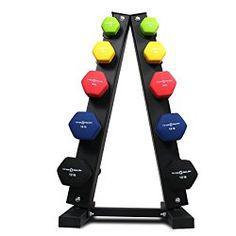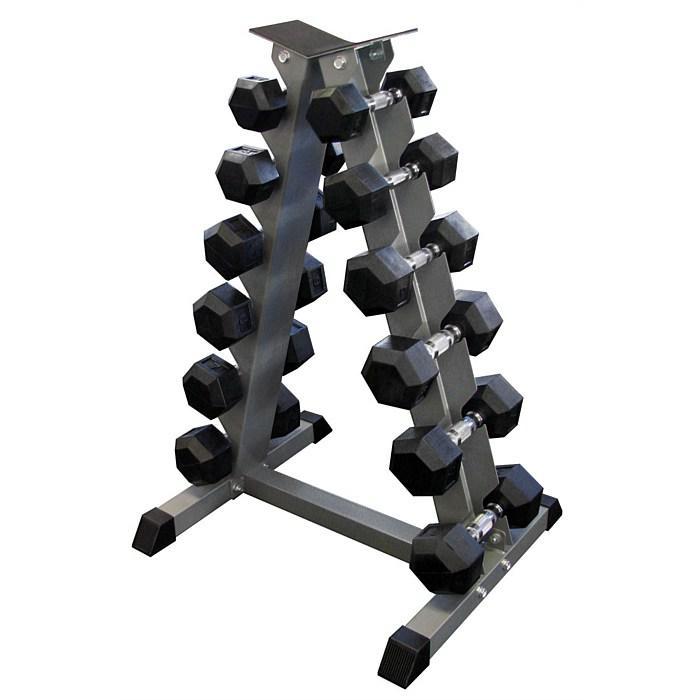The first image is the image on the left, the second image is the image on the right. Examine the images to the left and right. Is the description "Two metal racks for weights are trangular shaped, one of them black with various colored weights, the other gray with black weights." accurate? Answer yes or no. Yes. The first image is the image on the left, the second image is the image on the right. Given the left and right images, does the statement "There are two triangular shaped racks of dumbells in the pair of images." hold true? Answer yes or no. Yes. 